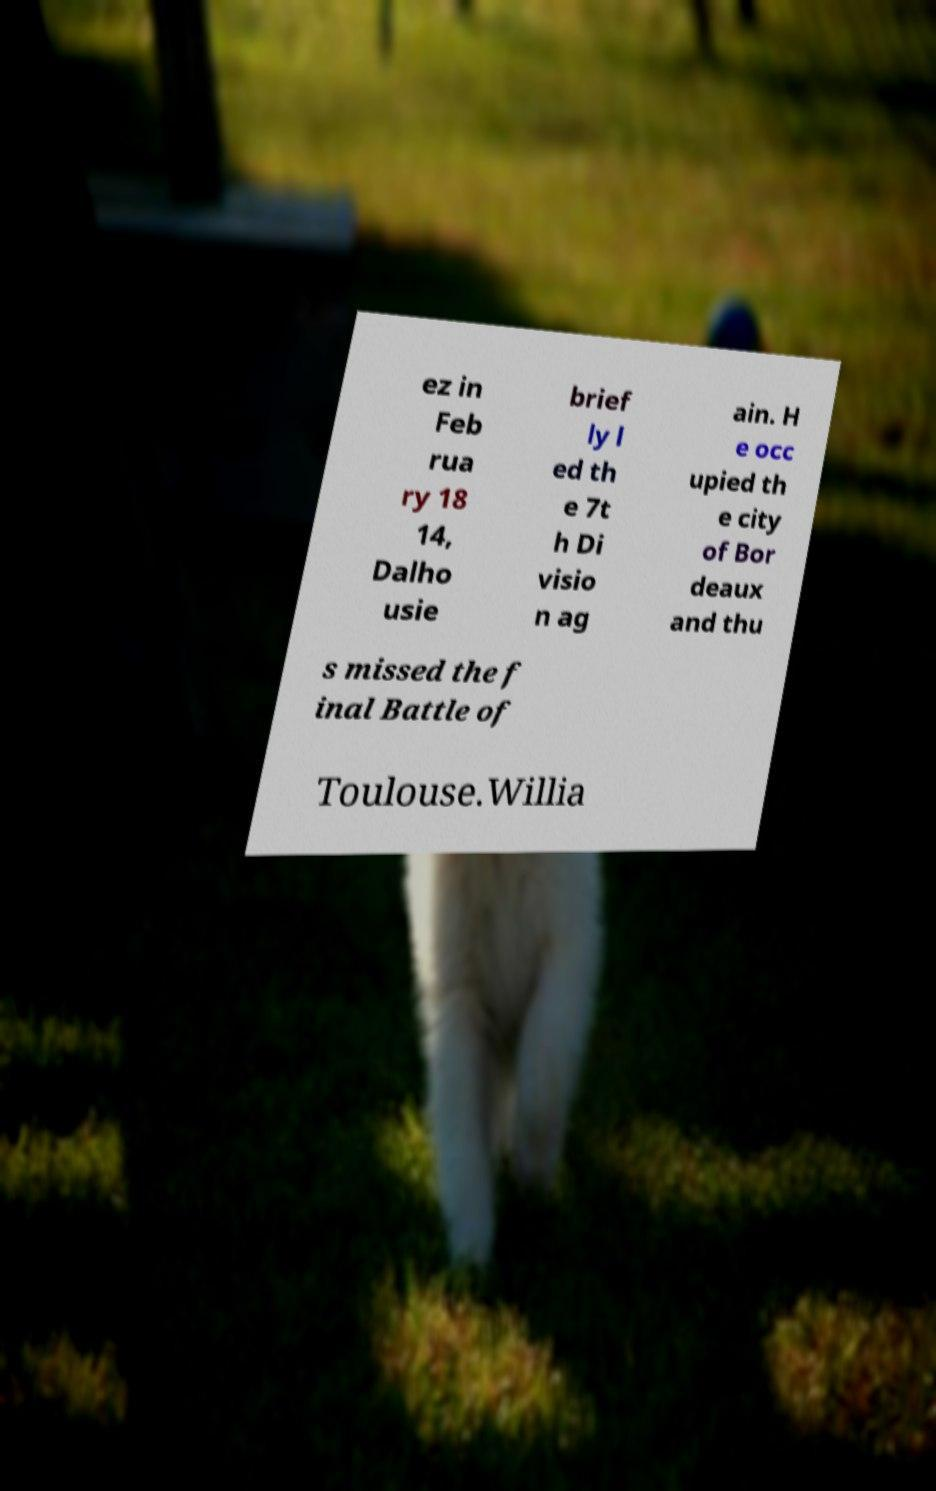Please identify and transcribe the text found in this image. ez in Feb rua ry 18 14, Dalho usie brief ly l ed th e 7t h Di visio n ag ain. H e occ upied th e city of Bor deaux and thu s missed the f inal Battle of Toulouse.Willia 